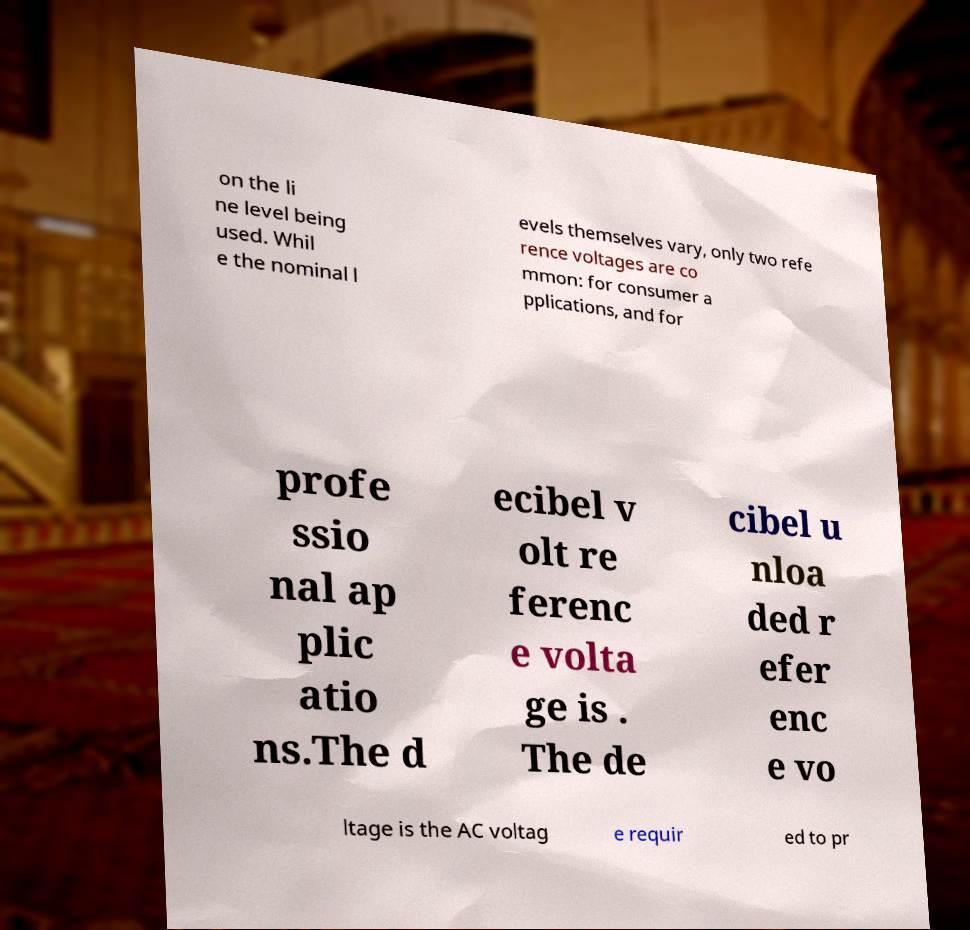What messages or text are displayed in this image? I need them in a readable, typed format. on the li ne level being used. Whil e the nominal l evels themselves vary, only two refe rence voltages are co mmon: for consumer a pplications, and for profe ssio nal ap plic atio ns.The d ecibel v olt re ferenc e volta ge is . The de cibel u nloa ded r efer enc e vo ltage is the AC voltag e requir ed to pr 